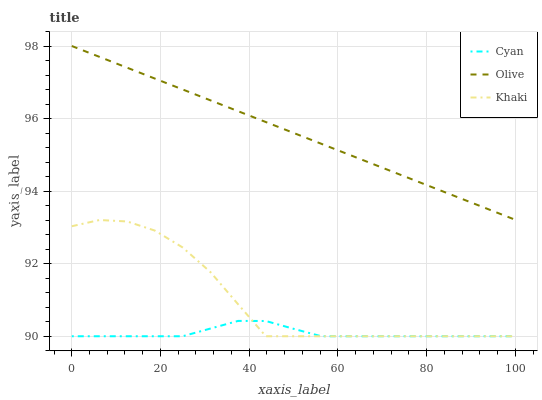Does Cyan have the minimum area under the curve?
Answer yes or no. Yes. Does Olive have the maximum area under the curve?
Answer yes or no. Yes. Does Khaki have the minimum area under the curve?
Answer yes or no. No. Does Khaki have the maximum area under the curve?
Answer yes or no. No. Is Olive the smoothest?
Answer yes or no. Yes. Is Khaki the roughest?
Answer yes or no. Yes. Is Cyan the smoothest?
Answer yes or no. No. Is Cyan the roughest?
Answer yes or no. No. Does Cyan have the lowest value?
Answer yes or no. Yes. Does Olive have the highest value?
Answer yes or no. Yes. Does Khaki have the highest value?
Answer yes or no. No. Is Khaki less than Olive?
Answer yes or no. Yes. Is Olive greater than Khaki?
Answer yes or no. Yes. Does Khaki intersect Cyan?
Answer yes or no. Yes. Is Khaki less than Cyan?
Answer yes or no. No. Is Khaki greater than Cyan?
Answer yes or no. No. Does Khaki intersect Olive?
Answer yes or no. No. 